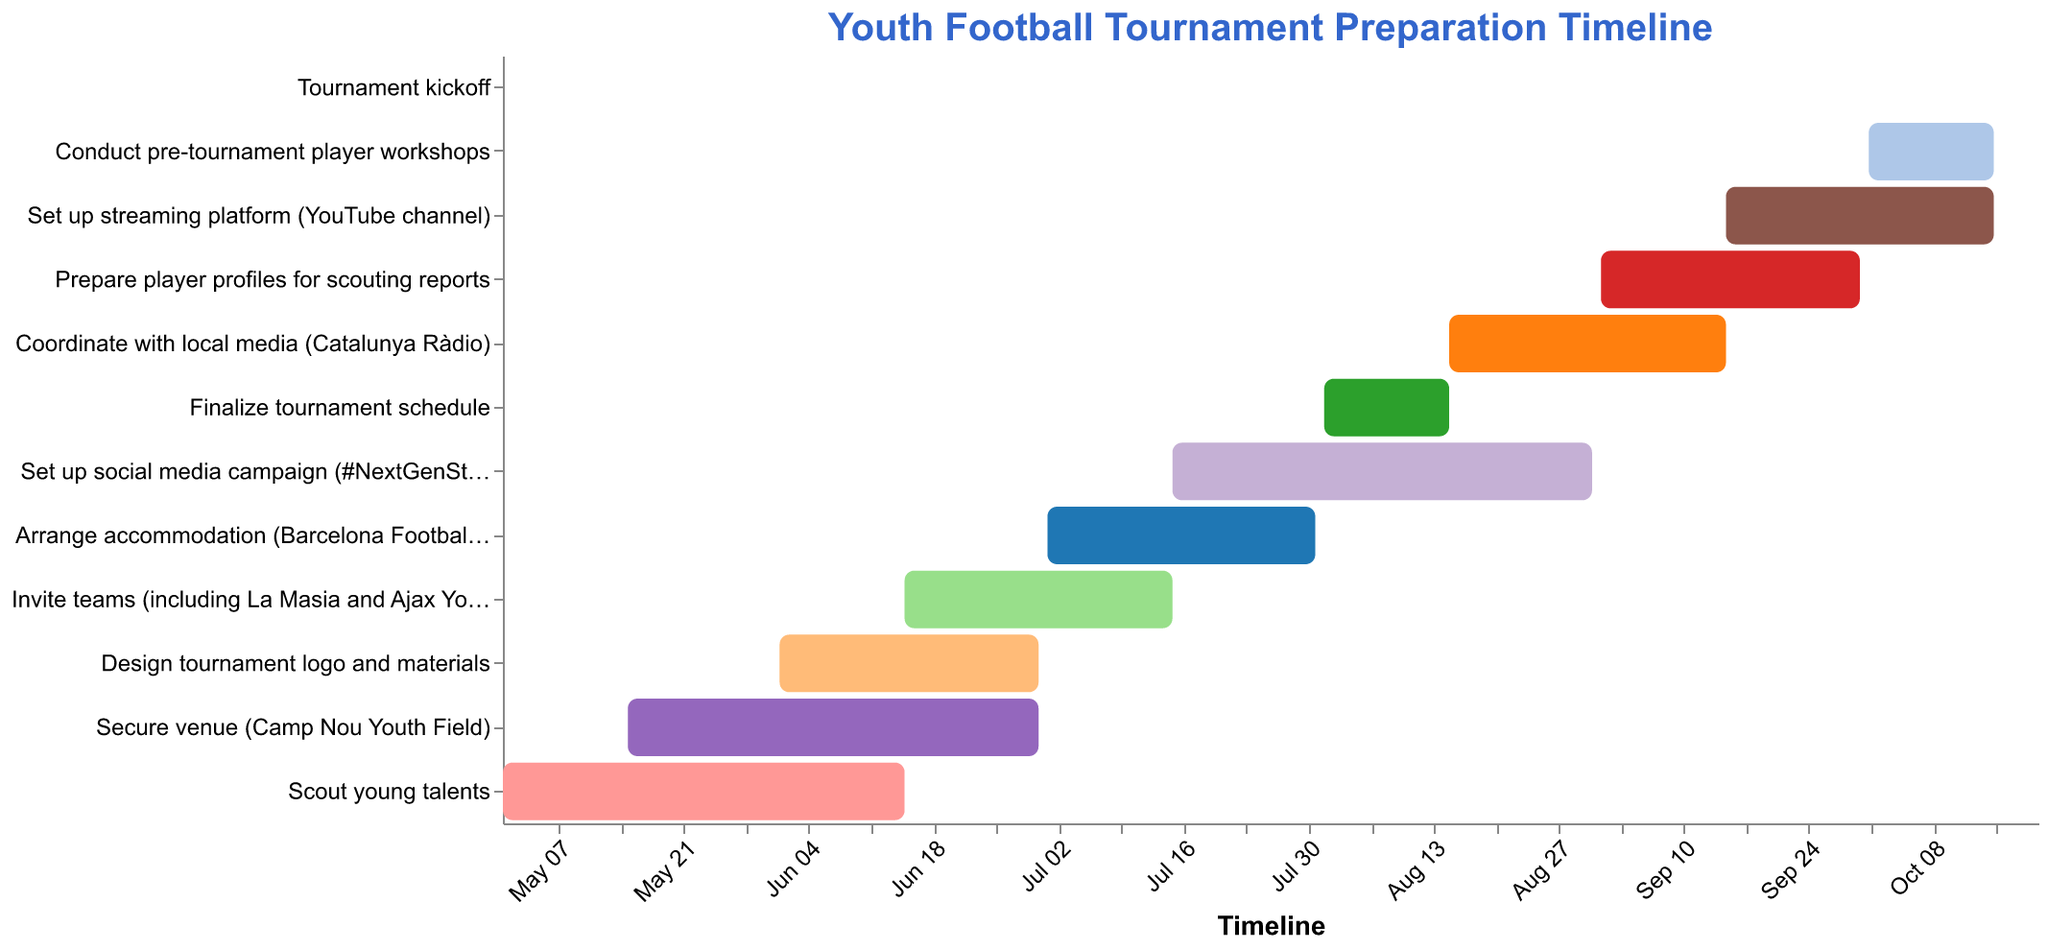What is the title of the Gantt Chart? The title is typically located at the top of the chart and describes the overall content or purpose of the chart. In this case, it identifies the event and purpose.
Answer: Youth Football Tournament Preparation Timeline What task has the earliest start date? By examining the leftmost start date point on the timeline axis, you can identify the task with the earliest starting time.
Answer: Scout young talents In total, how many months does the preparation cover from the earliest start date to the latest end date? The earliest start date is May 1, 2023, and the latest end date is October 20, 2023. Counting the months between these dates gives the total preparation duration.
Answer: 6 months How long does the "Coordinate with local media" task last? The start date is August 15, 2023, and the end date is September 15, 2023. To find the duration, calculate the difference between these two dates.
Answer: 1 month Which tasks take place entirely in August 2023? By checking the timeline axis, identify tasks whose start and end dates fall within August 2023.
Answer: Finalize tournament schedule, Set up social media campaign Which task overlaps with the period of "Design tournament logo and materials"? Look for tasks whose start and end dates intersect with the period from June 1, 2023, to June 30, 2023.
Answer: Design tournament logo and materials, Secure venue, Invite teams Which task is the final activity before the tournament kickoff? The Gantt Chart visually sequences tasks leading up to the final event. Find the task bar that comes immediately before the tournament kickoff date on the timeline.
Answer: Conduct pre-tournament player workshops How many tasks are scheduled to run past the start of September 2023? By checking the start and end dates, count the number of tasks that continue beyond September 1, 2023.
Answer: 5 tasks 